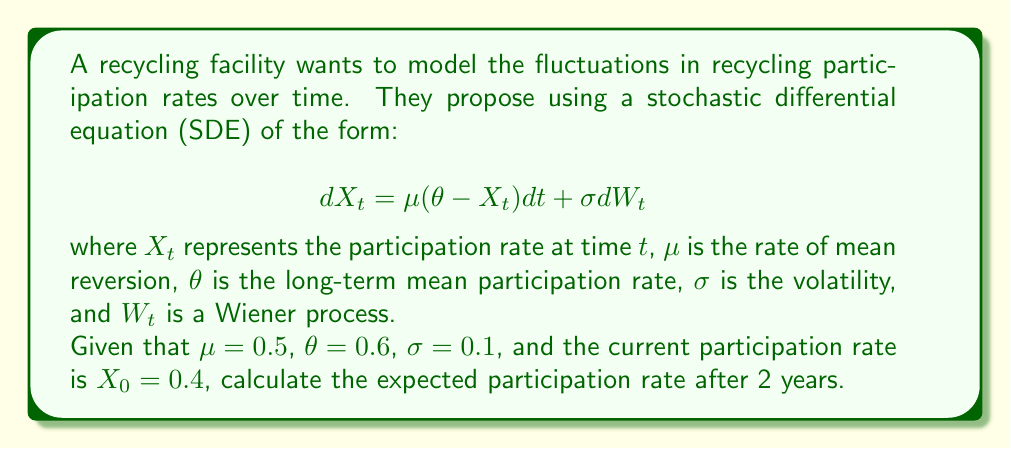What is the answer to this math problem? To solve this problem, we need to use the properties of the Ornstein-Uhlenbeck process, which is described by the given SDE. The solution for the expected value of $X_t$ given $X_0$ is:

$$E[X_t|X_0] = \theta + (X_0 - \theta)e^{-\mu t}$$

Let's follow these steps:

1) Identify the parameters:
   $\mu = 0.5$
   $\theta = 0.6$
   $X_0 = 0.4$
   $t = 2$ years

2) Substitute these values into the formula:

   $$E[X_2|X_0] = 0.6 + (0.4 - 0.6)e^{-0.5 \cdot 2}$$

3) Simplify the exponent:
   $$e^{-0.5 \cdot 2} = e^{-1} \approx 0.3679$$

4) Calculate the result:
   $$E[X_2|X_0] = 0.6 + (-0.2 \cdot 0.3679)$$
   $$E[X_2|X_0] = 0.6 - 0.07358$$
   $$E[X_2|X_0] = 0.52642$$

Therefore, the expected participation rate after 2 years is approximately 0.52642 or 52.642%.
Answer: 0.52642 